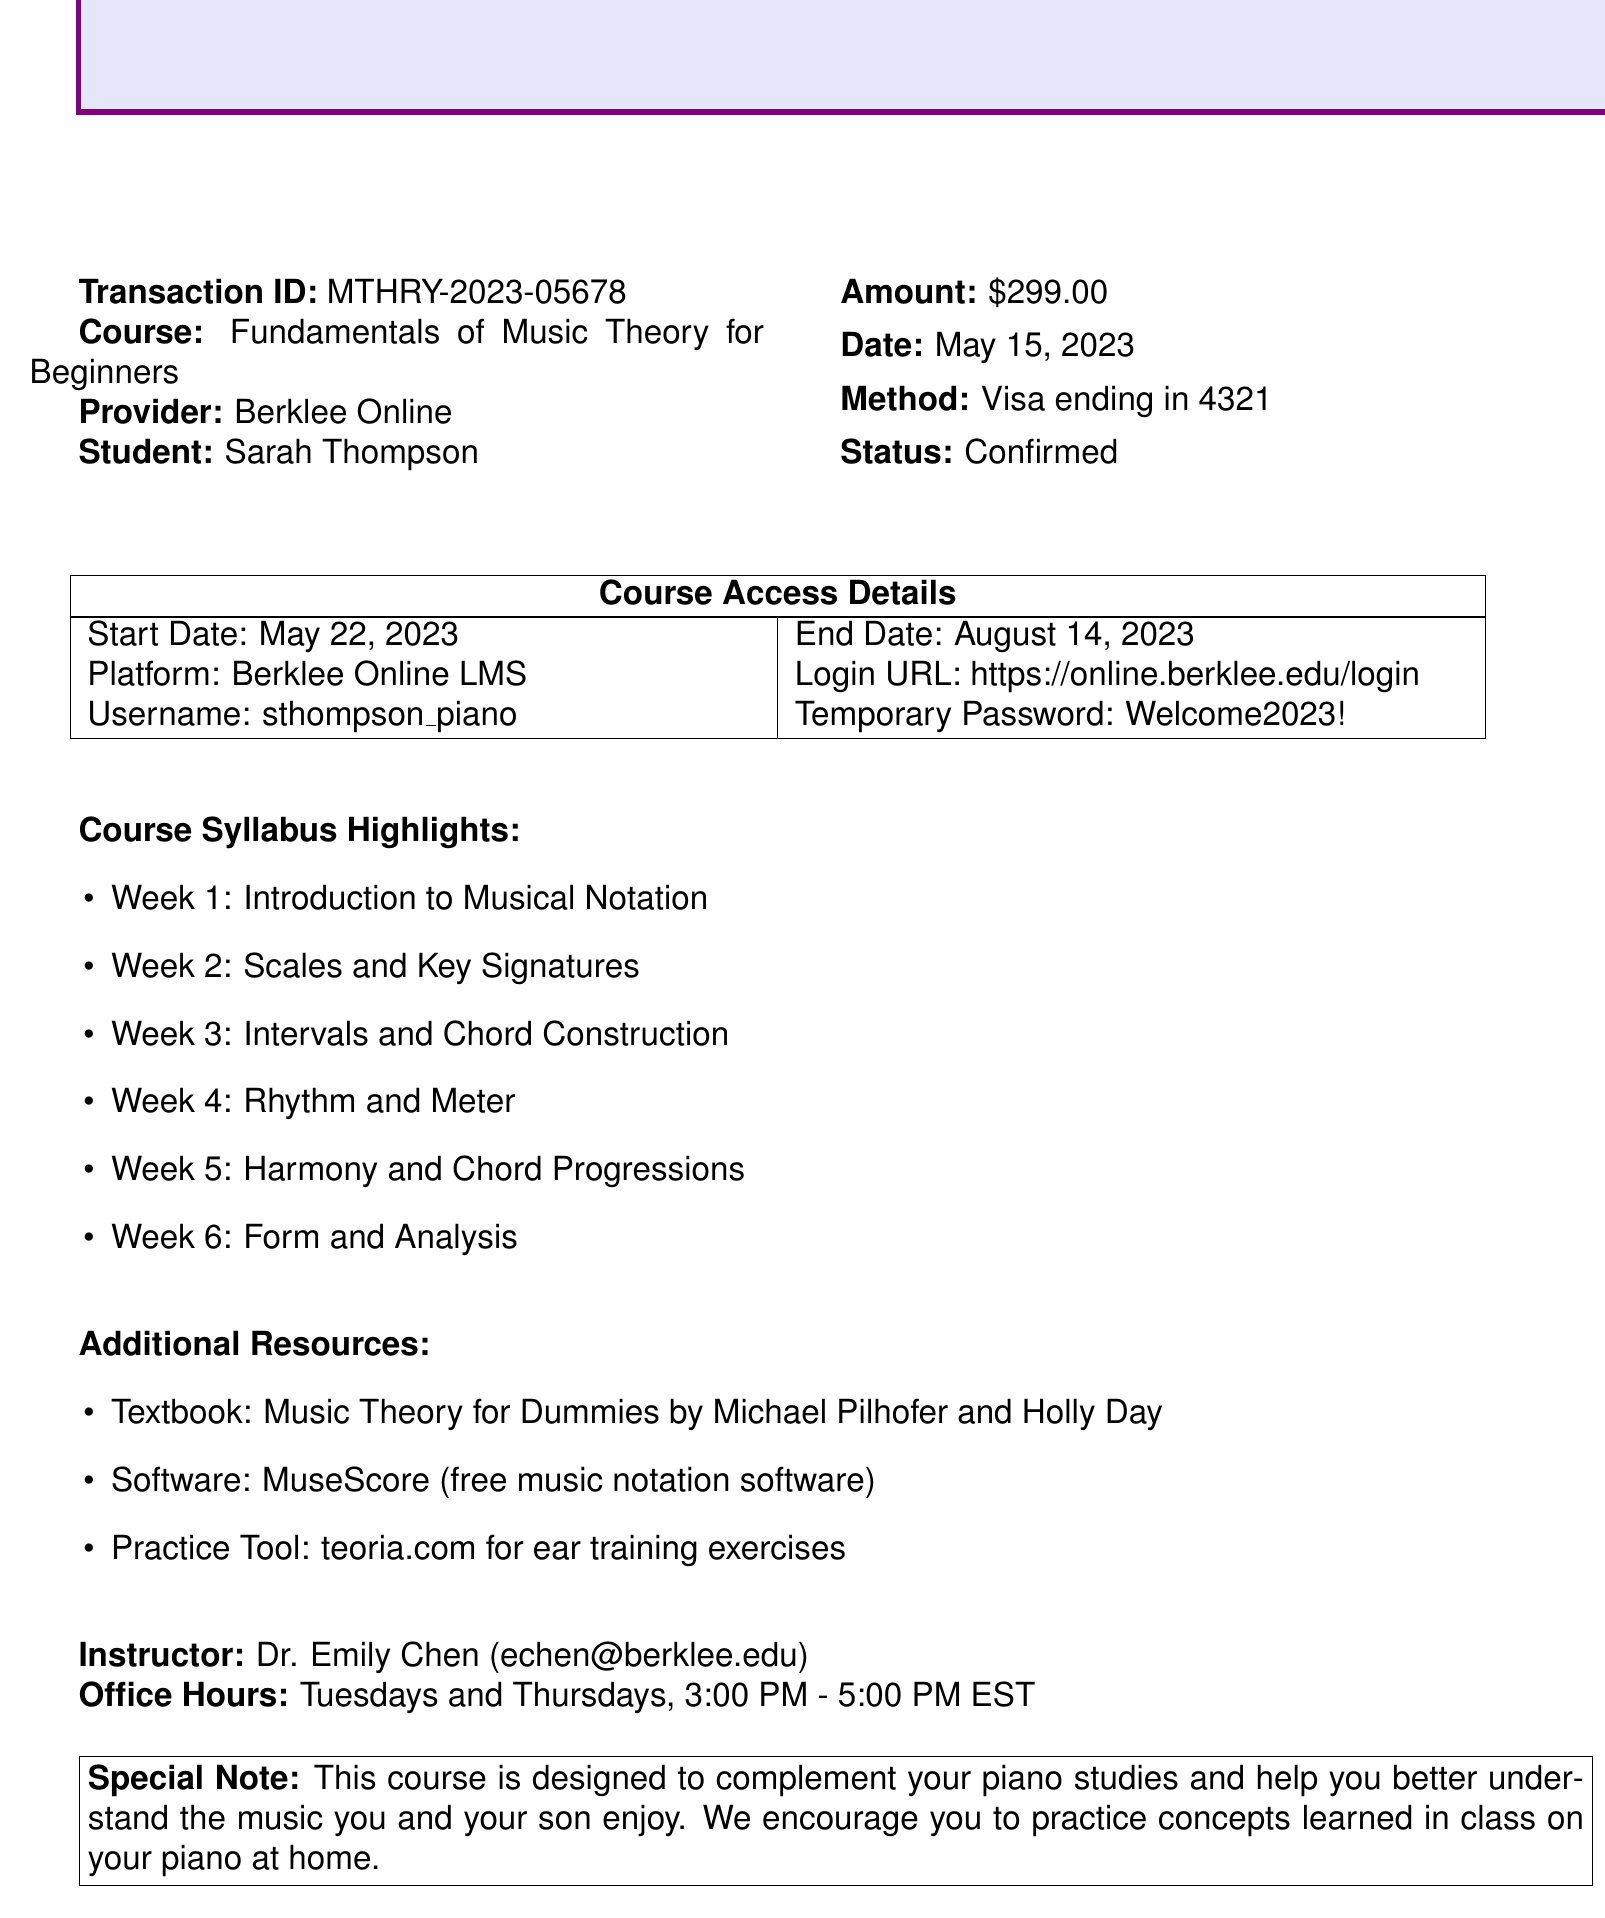What is the transaction ID? The transaction ID is a unique identifier provided in the document for tracking purposes.
Answer: MTHRY-2023-05678 What is the course name? The course name is mentioned prominently in the document as the subject of the transaction.
Answer: Fundamentals of Music Theory for Beginners Who is the course provider? The provider of the course is listed in the document, indicating the organization offering the course.
Answer: Berklee Online What is the payment method used? The payment method indicates how the course fee was settled and is detailed in the payment section.
Answer: Visa ending in 4321 When does the course start? The start date for accessing course material is specified in the course access details section.
Answer: May 22, 2023 What is the name of the instructor? The document lists the instructor's name, which is essential for contacting her for questions or assistance.
Answer: Dr. Emily Chen How many weeks is the course? To find the course duration from the syllabus highlights helps understand the study period.
Answer: 6 What is the special note about the course? The special note reinforces how the course connects to piano studies, providing motivation for personal practice.
Answer: This course is designed to complement your piano studies and help you better understand the music you and your son enjoy What additional software is recommended for this course? The additional resources section indicates tools that will assist in learning the material better.
Answer: MuseScore 